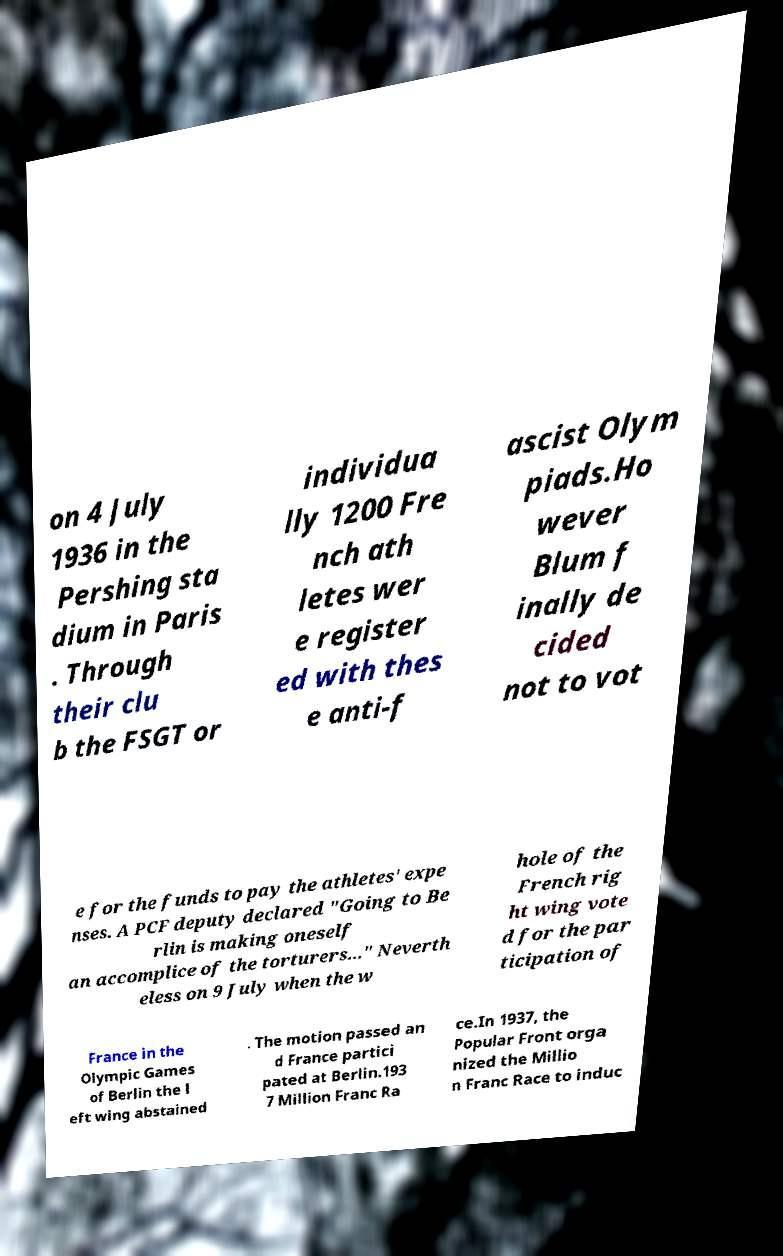Could you extract and type out the text from this image? on 4 July 1936 in the Pershing sta dium in Paris . Through their clu b the FSGT or individua lly 1200 Fre nch ath letes wer e register ed with thes e anti-f ascist Olym piads.Ho wever Blum f inally de cided not to vot e for the funds to pay the athletes' expe nses. A PCF deputy declared "Going to Be rlin is making oneself an accomplice of the torturers..." Neverth eless on 9 July when the w hole of the French rig ht wing vote d for the par ticipation of France in the Olympic Games of Berlin the l eft wing abstained . The motion passed an d France partici pated at Berlin.193 7 Million Franc Ra ce.In 1937, the Popular Front orga nized the Millio n Franc Race to induc 